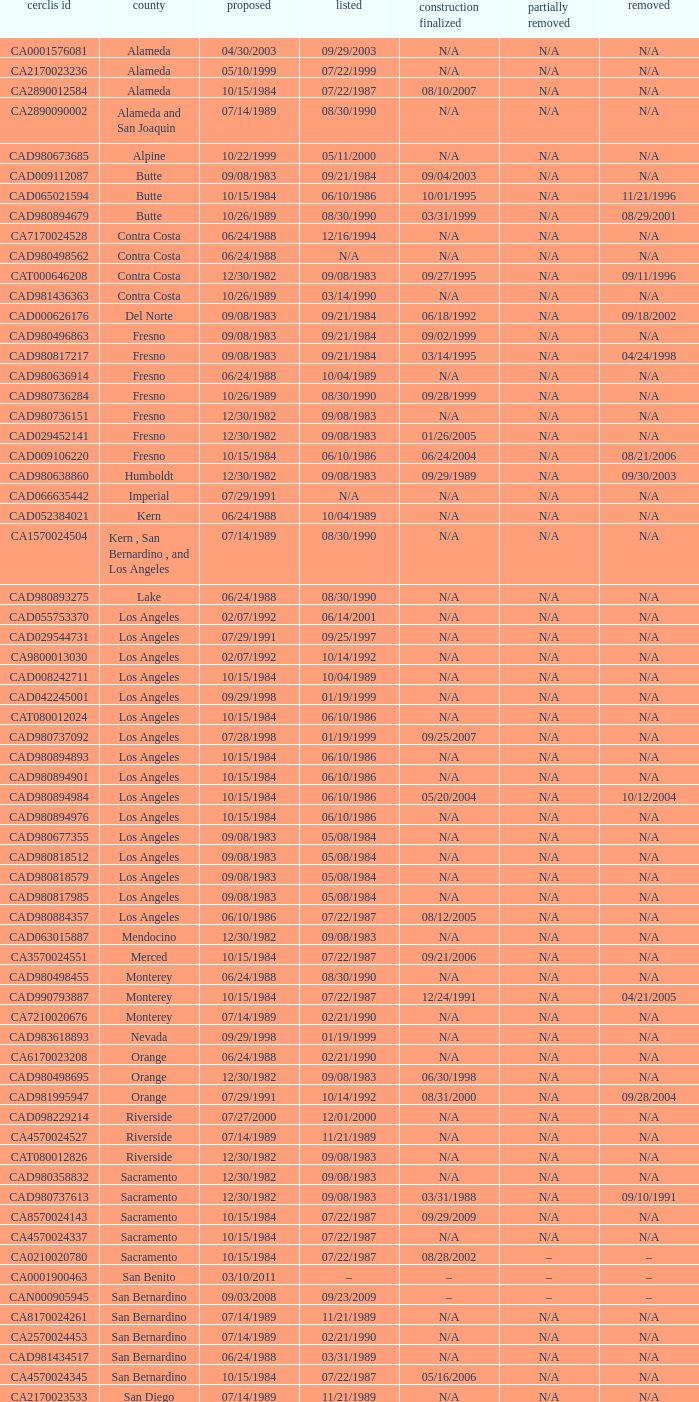What construction completed on 08/10/2007? 07/22/1987. 